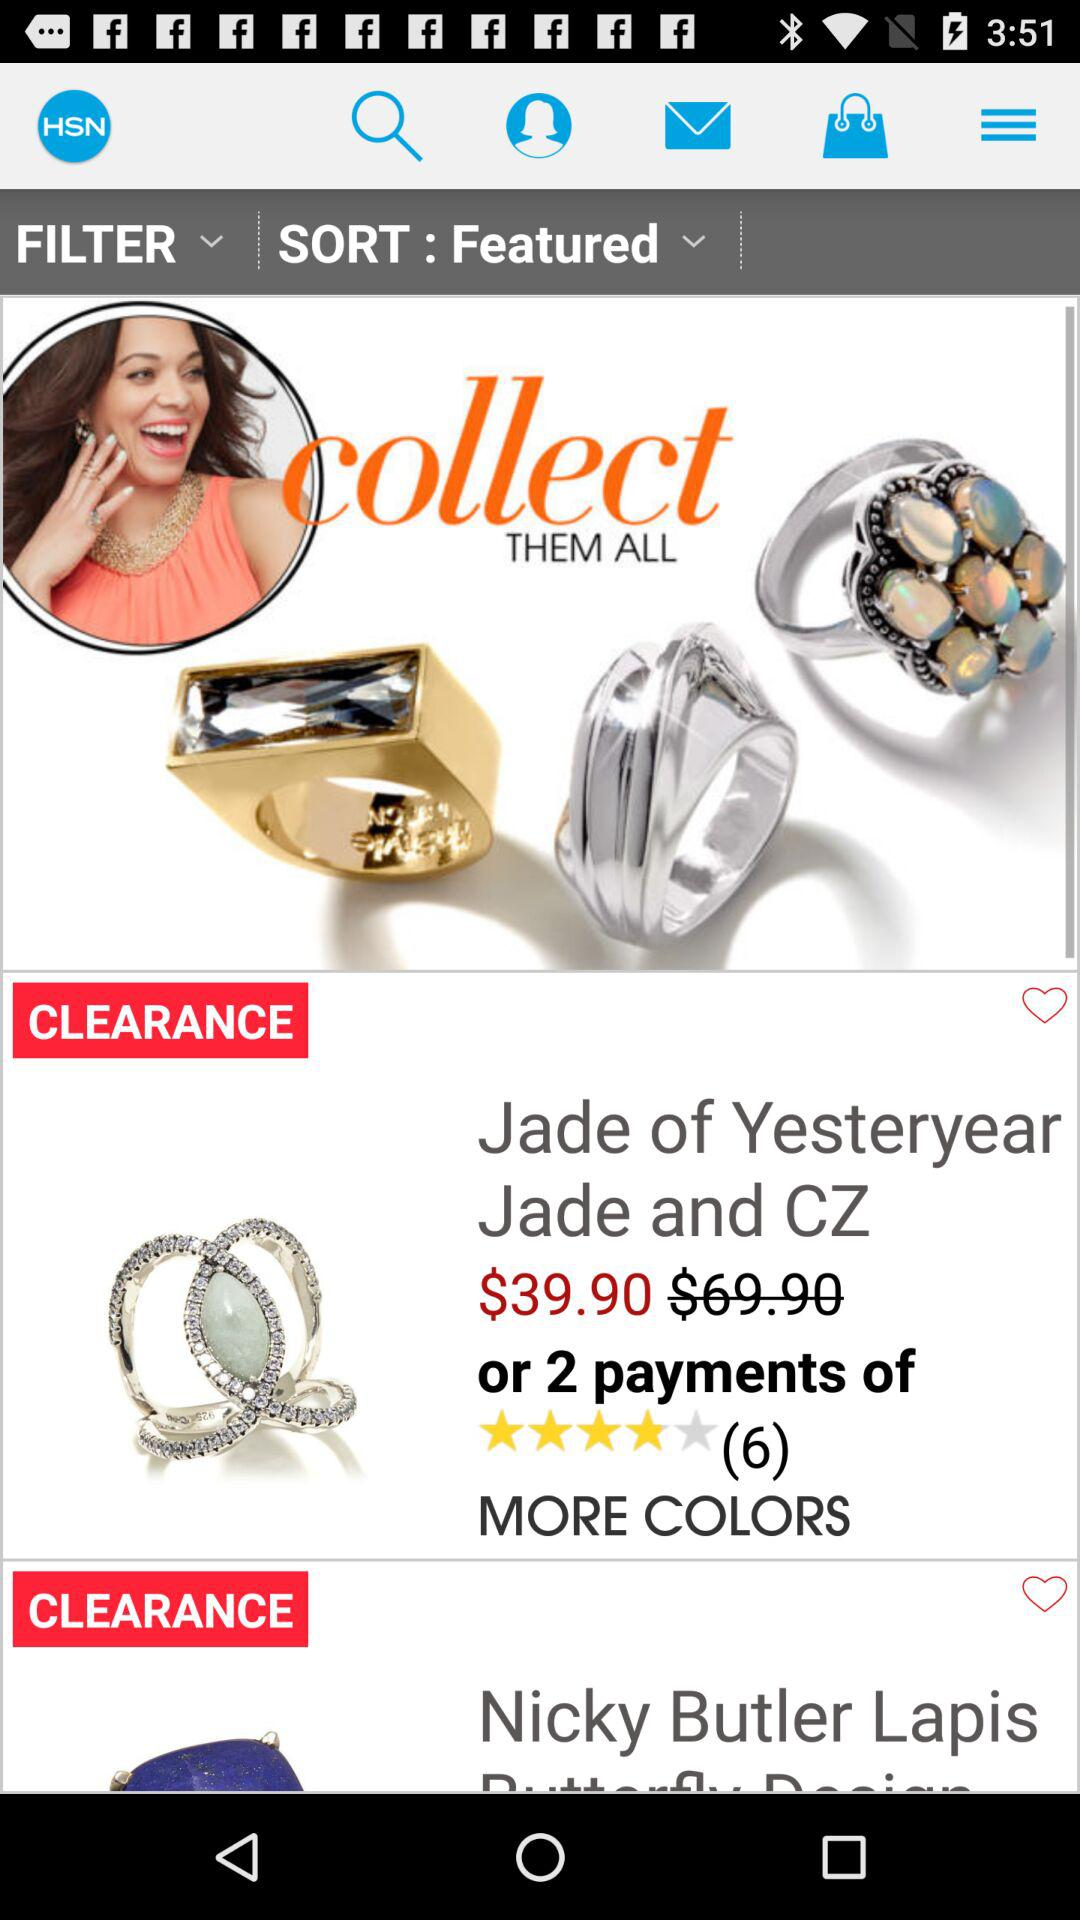What option is selected in the sort? The selected option is "Featured". 